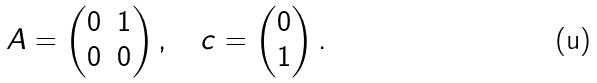<formula> <loc_0><loc_0><loc_500><loc_500>A = \begin{pmatrix} 0 & 1 \\ 0 & 0 \end{pmatrix} , \quad c = \begin{pmatrix} 0 \\ 1 \end{pmatrix} .</formula> 